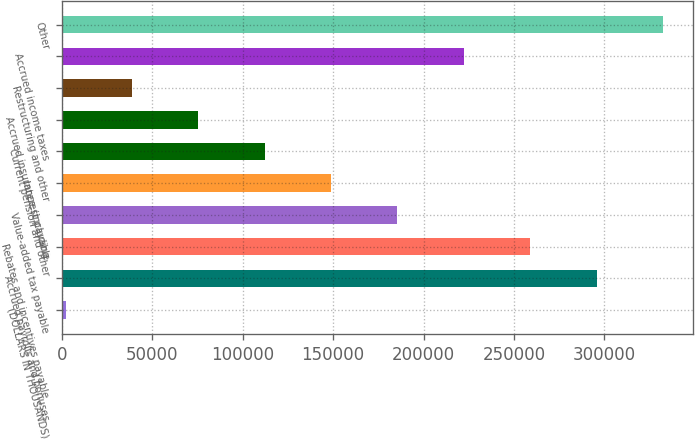<chart> <loc_0><loc_0><loc_500><loc_500><bar_chart><fcel>(DOLLARS IN THOUSANDS)<fcel>Accrued payrolls and bonuses<fcel>Rebates and incentives payable<fcel>Value-added tax payable<fcel>Interest payable<fcel>Current pension and other<fcel>Accrued insurance (including<fcel>Restructuring and other<fcel>Accrued income taxes<fcel>Other<nl><fcel>2017<fcel>295759<fcel>259041<fcel>185606<fcel>148888<fcel>112170<fcel>75452.4<fcel>38734.7<fcel>222323<fcel>332476<nl></chart> 